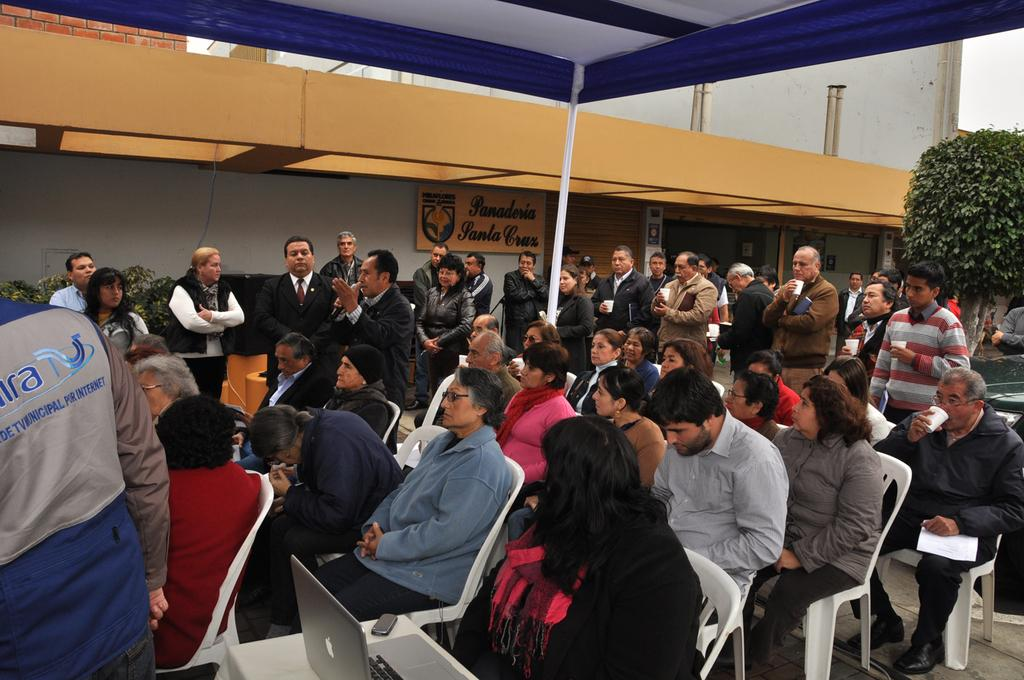What are the people in the image doing? The people in the image are sitting on chairs. What electronic device can be seen in the image? There is a laptop in the image. What type of vegetation is present in the image? There are plants in the image. What surface can be used for writing or displaying information in the image? There is a board in the image. What type of cup can be seen in the image? There is no cup present in the image. 